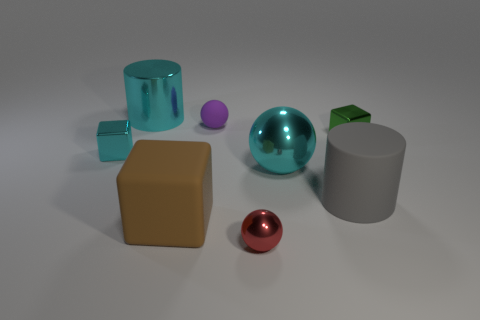Add 2 tiny cyan things. How many objects exist? 10 Subtract all spheres. How many objects are left? 5 Add 8 green metal blocks. How many green metal blocks exist? 9 Subtract 0 blue cylinders. How many objects are left? 8 Subtract all green metal cubes. Subtract all green metallic cubes. How many objects are left? 6 Add 3 cyan balls. How many cyan balls are left? 4 